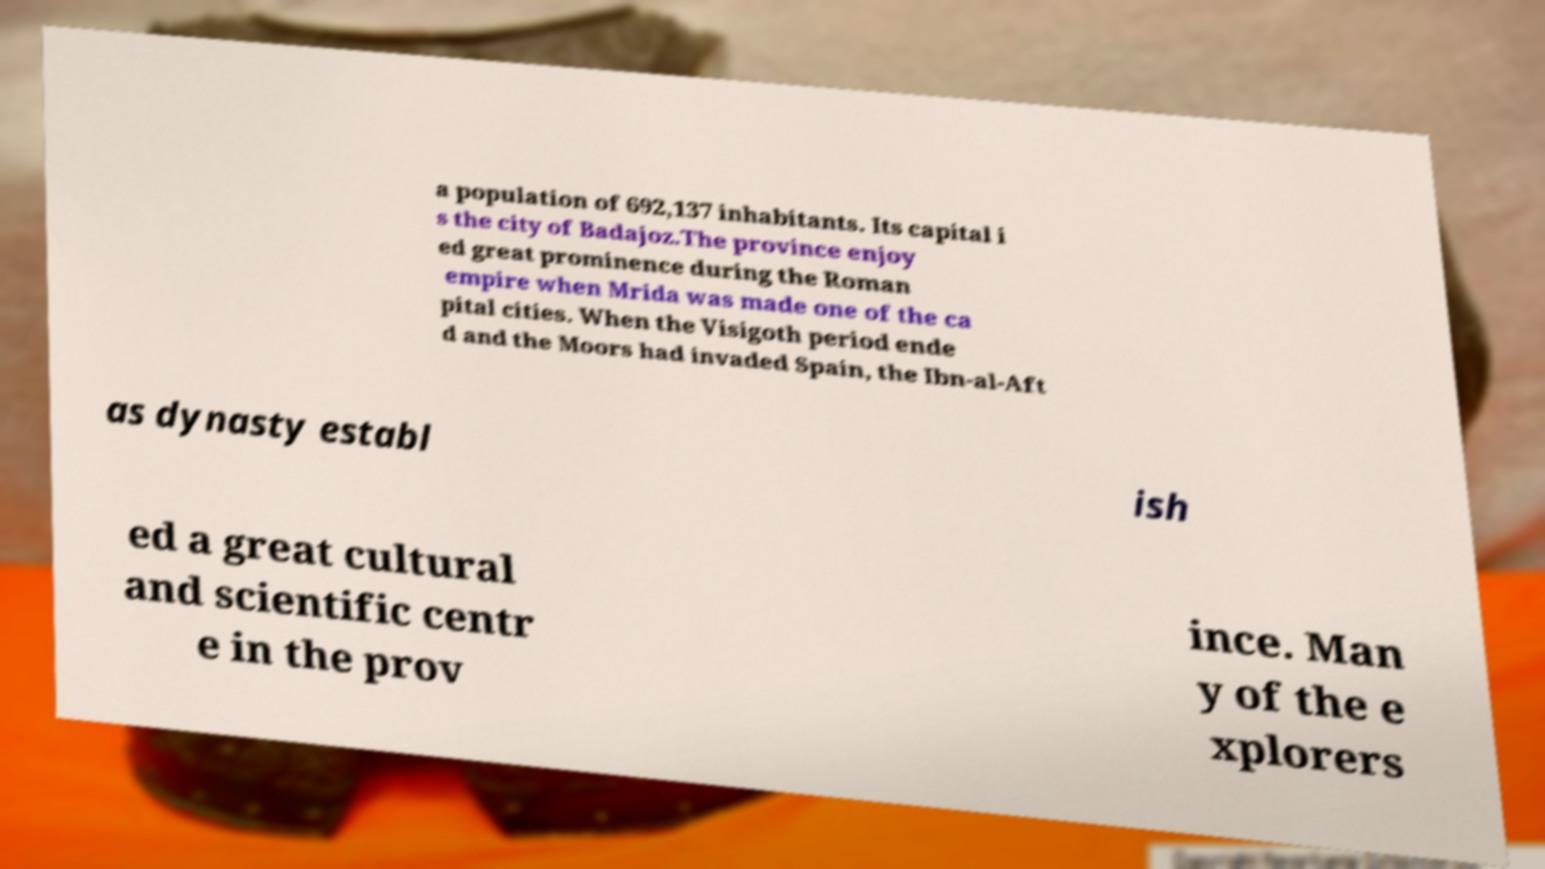For documentation purposes, I need the text within this image transcribed. Could you provide that? a population of 692,137 inhabitants. Its capital i s the city of Badajoz.The province enjoy ed great prominence during the Roman empire when Mrida was made one of the ca pital cities. When the Visigoth period ende d and the Moors had invaded Spain, the Ibn-al-Aft as dynasty establ ish ed a great cultural and scientific centr e in the prov ince. Man y of the e xplorers 